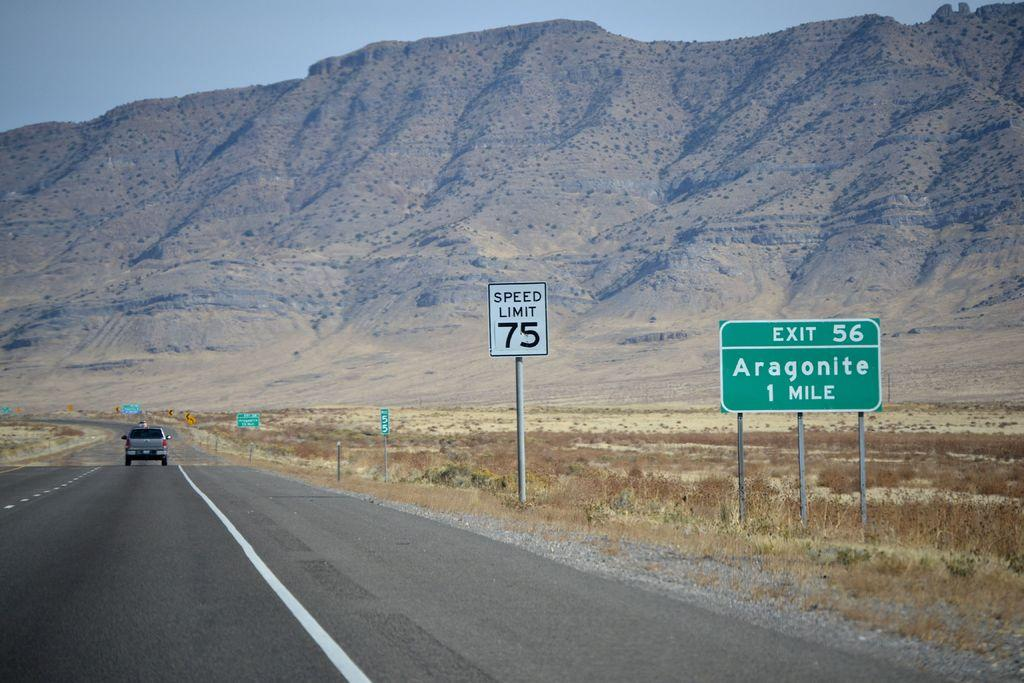<image>
Relay a brief, clear account of the picture shown. A single SUV on a road in the desert approaching mountains passes a road sign indicating that Exit 56 for Aragonite is in one mile. 